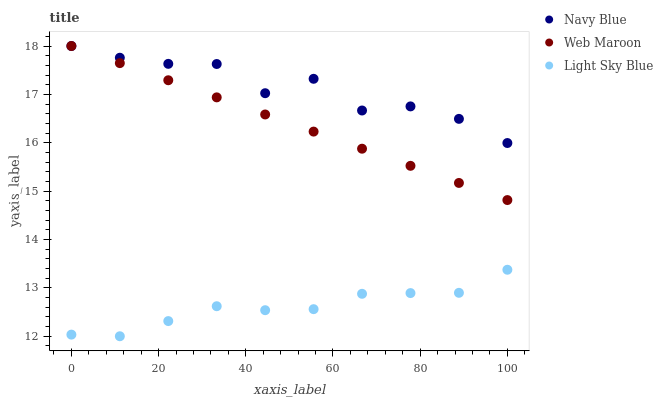Does Light Sky Blue have the minimum area under the curve?
Answer yes or no. Yes. Does Navy Blue have the maximum area under the curve?
Answer yes or no. Yes. Does Web Maroon have the minimum area under the curve?
Answer yes or no. No. Does Web Maroon have the maximum area under the curve?
Answer yes or no. No. Is Web Maroon the smoothest?
Answer yes or no. Yes. Is Navy Blue the roughest?
Answer yes or no. Yes. Is Light Sky Blue the smoothest?
Answer yes or no. No. Is Light Sky Blue the roughest?
Answer yes or no. No. Does Light Sky Blue have the lowest value?
Answer yes or no. Yes. Does Web Maroon have the lowest value?
Answer yes or no. No. Does Web Maroon have the highest value?
Answer yes or no. Yes. Does Light Sky Blue have the highest value?
Answer yes or no. No. Is Light Sky Blue less than Web Maroon?
Answer yes or no. Yes. Is Web Maroon greater than Light Sky Blue?
Answer yes or no. Yes. Does Web Maroon intersect Navy Blue?
Answer yes or no. Yes. Is Web Maroon less than Navy Blue?
Answer yes or no. No. Is Web Maroon greater than Navy Blue?
Answer yes or no. No. Does Light Sky Blue intersect Web Maroon?
Answer yes or no. No. 